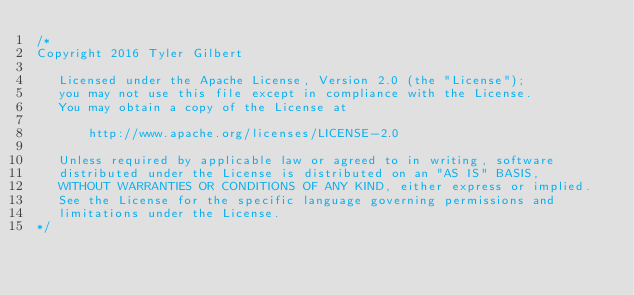Convert code to text. <code><loc_0><loc_0><loc_500><loc_500><_C_>/*
Copyright 2016 Tyler Gilbert

   Licensed under the Apache License, Version 2.0 (the "License");
   you may not use this file except in compliance with the License.
   You may obtain a copy of the License at

       http://www.apache.org/licenses/LICENSE-2.0

   Unless required by applicable law or agreed to in writing, software
   distributed under the License is distributed on an "AS IS" BASIS,
   WITHOUT WARRANTIES OR CONDITIONS OF ANY KIND, either express or implied.
   See the License for the specific language governing permissions and
   limitations under the License.
*/
</code> 